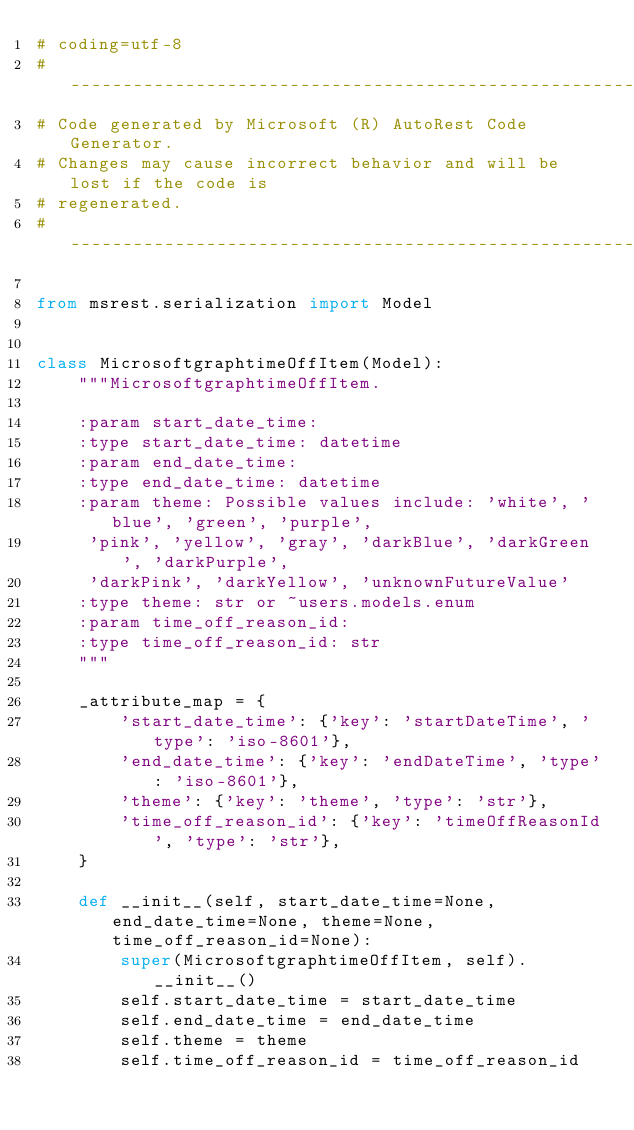<code> <loc_0><loc_0><loc_500><loc_500><_Python_># coding=utf-8
# --------------------------------------------------------------------------
# Code generated by Microsoft (R) AutoRest Code Generator.
# Changes may cause incorrect behavior and will be lost if the code is
# regenerated.
# --------------------------------------------------------------------------

from msrest.serialization import Model


class MicrosoftgraphtimeOffItem(Model):
    """MicrosoftgraphtimeOffItem.

    :param start_date_time:
    :type start_date_time: datetime
    :param end_date_time:
    :type end_date_time: datetime
    :param theme: Possible values include: 'white', 'blue', 'green', 'purple',
     'pink', 'yellow', 'gray', 'darkBlue', 'darkGreen', 'darkPurple',
     'darkPink', 'darkYellow', 'unknownFutureValue'
    :type theme: str or ~users.models.enum
    :param time_off_reason_id:
    :type time_off_reason_id: str
    """

    _attribute_map = {
        'start_date_time': {'key': 'startDateTime', 'type': 'iso-8601'},
        'end_date_time': {'key': 'endDateTime', 'type': 'iso-8601'},
        'theme': {'key': 'theme', 'type': 'str'},
        'time_off_reason_id': {'key': 'timeOffReasonId', 'type': 'str'},
    }

    def __init__(self, start_date_time=None, end_date_time=None, theme=None, time_off_reason_id=None):
        super(MicrosoftgraphtimeOffItem, self).__init__()
        self.start_date_time = start_date_time
        self.end_date_time = end_date_time
        self.theme = theme
        self.time_off_reason_id = time_off_reason_id
</code> 